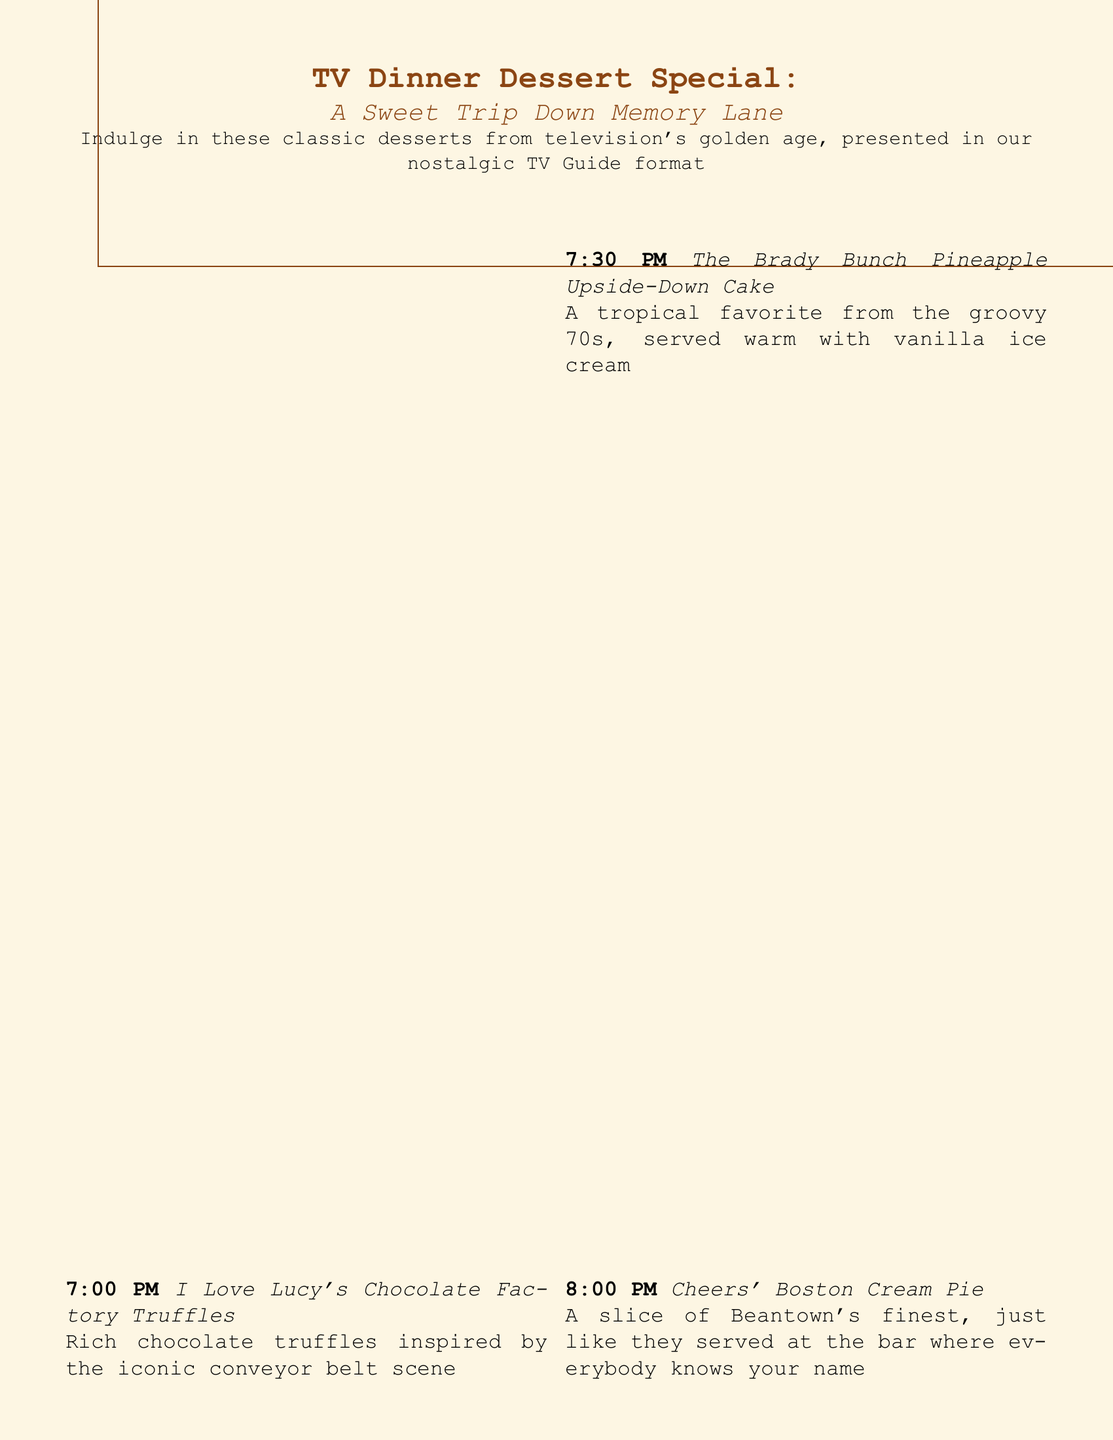What is the first dessert listed? The first dessert listed is from "I Love Lucy," which refers to the chocolate truffles associated with the show.
Answer: I Love Lucy's Chocolate Factory Truffles What time does the "Boston Cream Pie" dessert appear? The "Boston Cream Pie" is featured at 8:00 PM, right after the previous dessert.
Answer: 8:00 PM Which dessert is inspired by a scene from "I Love Lucy"? The dessert inspired by "I Love Lucy" is rich chocolate truffles related to the famous conveyor belt scene.
Answer: Chocolate Factory Truffles How many desserts are offered in total? The menu includes 6 different nostalgic desserts, each associated with classic TV shows.
Answer: 6 What is served with the "Pineapple Upside-Down Cake"? The menu states that the "Pineapple Upside-Down Cake" is served warm with vanilla ice cream, enhancing its tropical flavor.
Answer: vanilla ice cream Which dessert serves as a palate cleanser? The dessert intended to refresh the palate is Aunt Bee's Kerosene Cucumber Pickles from "The Andy Griffith Show."
Answer: Kerosene Cucumber Pickles What is a common theme connecting the desserts? The desserts connect through nostalgia and references to classic TV shows from the golden age of television.
Answer: Nostalgia What beverage style is represented by the "Malted Milkshake"? The Malted Milkshake represented connects to the iconic soda fountain beverage popular in the jukebox era of the 1950s.
Answer: Creamy, frothy delight 